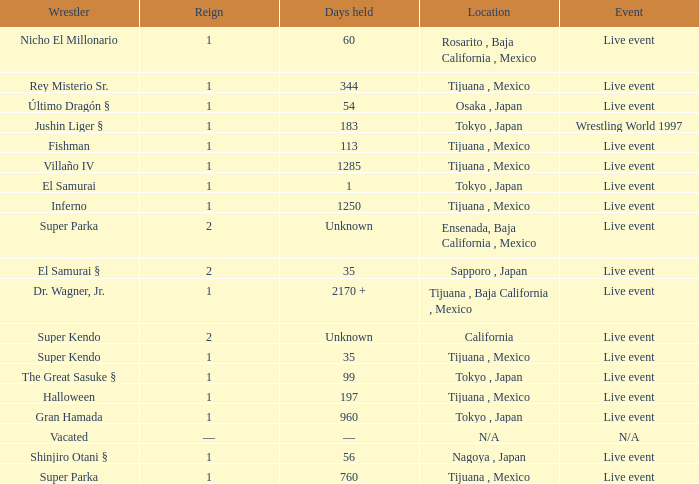What type of event had the wrestler with a reign of 2 and held the title for 35 days? Live event. Could you parse the entire table? {'header': ['Wrestler', 'Reign', 'Days held', 'Location', 'Event'], 'rows': [['Nicho El Millonario', '1', '60', 'Rosarito , Baja California , Mexico', 'Live event'], ['Rey Misterio Sr.', '1', '344', 'Tijuana , Mexico', 'Live event'], ['Último Dragón §', '1', '54', 'Osaka , Japan', 'Live event'], ['Jushin Liger §', '1', '183', 'Tokyo , Japan', 'Wrestling World 1997'], ['Fishman', '1', '113', 'Tijuana , Mexico', 'Live event'], ['Villaño IV', '1', '1285', 'Tijuana , Mexico', 'Live event'], ['El Samurai', '1', '1', 'Tokyo , Japan', 'Live event'], ['Inferno', '1', '1250', 'Tijuana , Mexico', 'Live event'], ['Super Parka', '2', 'Unknown', 'Ensenada, Baja California , Mexico', 'Live event'], ['El Samurai §', '2', '35', 'Sapporo , Japan', 'Live event'], ['Dr. Wagner, Jr.', '1', '2170 +', 'Tijuana , Baja California , Mexico', 'Live event'], ['Super Kendo', '2', 'Unknown', 'California', 'Live event'], ['Super Kendo', '1', '35', 'Tijuana , Mexico', 'Live event'], ['The Great Sasuke §', '1', '99', 'Tokyo , Japan', 'Live event'], ['Halloween', '1', '197', 'Tijuana , Mexico', 'Live event'], ['Gran Hamada', '1', '960', 'Tokyo , Japan', 'Live event'], ['Vacated', '—', '—', 'N/A', 'N/A'], ['Shinjiro Otani §', '1', '56', 'Nagoya , Japan', 'Live event'], ['Super Parka', '1', '760', 'Tijuana , Mexico', 'Live event']]} 